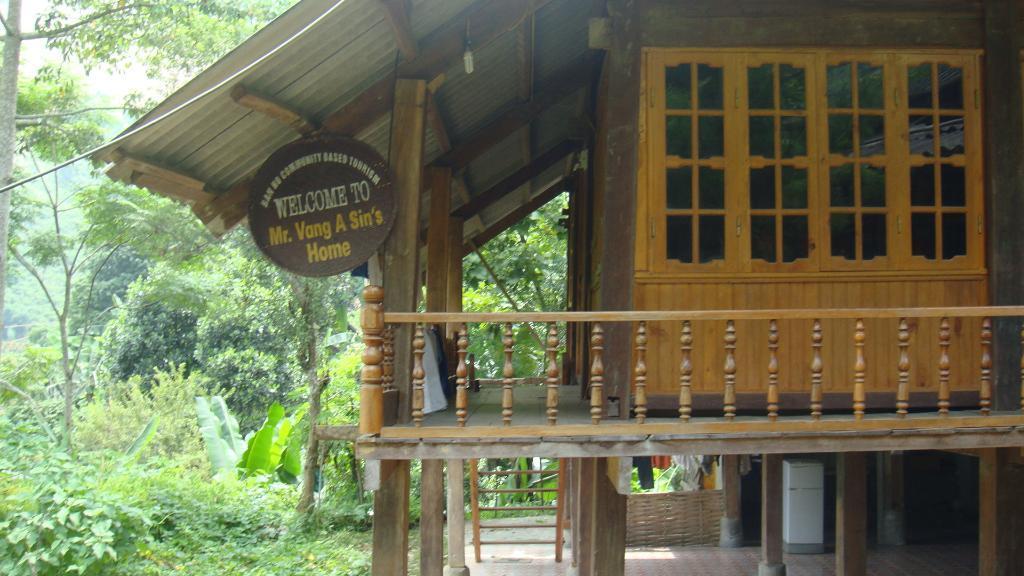Describe this image in one or two sentences. In this image we can see a wooden house with a board, there is a ladder, light, wooden fence, a white color object, clothes, and few trees on the left side. 